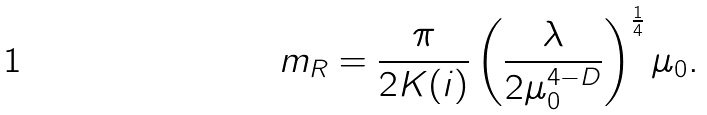Convert formula to latex. <formula><loc_0><loc_0><loc_500><loc_500>m _ { R } = \frac { \pi } { 2 K ( i ) } \left ( \frac { \lambda } { 2 \mu _ { 0 } ^ { 4 - D } } \right ) ^ { \frac { 1 } { 4 } } \mu _ { 0 } .</formula> 